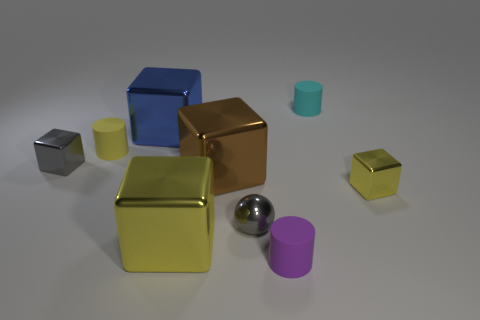Add 1 spheres. How many objects exist? 10 Subtract all yellow rubber cylinders. How many cylinders are left? 2 Subtract all spheres. How many objects are left? 8 Subtract 1 blue cubes. How many objects are left? 8 Subtract 1 balls. How many balls are left? 0 Subtract all green balls. Subtract all green cubes. How many balls are left? 1 Subtract all blue cylinders. How many purple balls are left? 0 Subtract all gray cubes. Subtract all purple rubber objects. How many objects are left? 7 Add 6 tiny rubber things. How many tiny rubber things are left? 9 Add 2 brown matte cubes. How many brown matte cubes exist? 2 